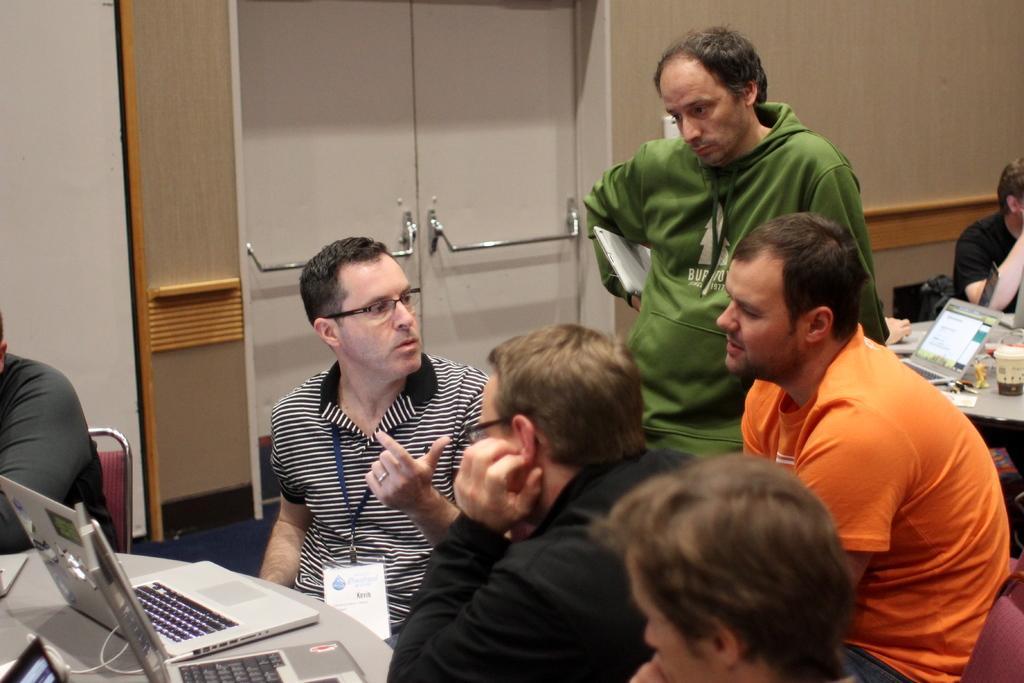Could you give a brief overview of what you see in this image? In the picture there are many people sitting on the chair with the table in front of them, on the table there are laptops present, there are cables, there is a wall, on the wall there is a door. 